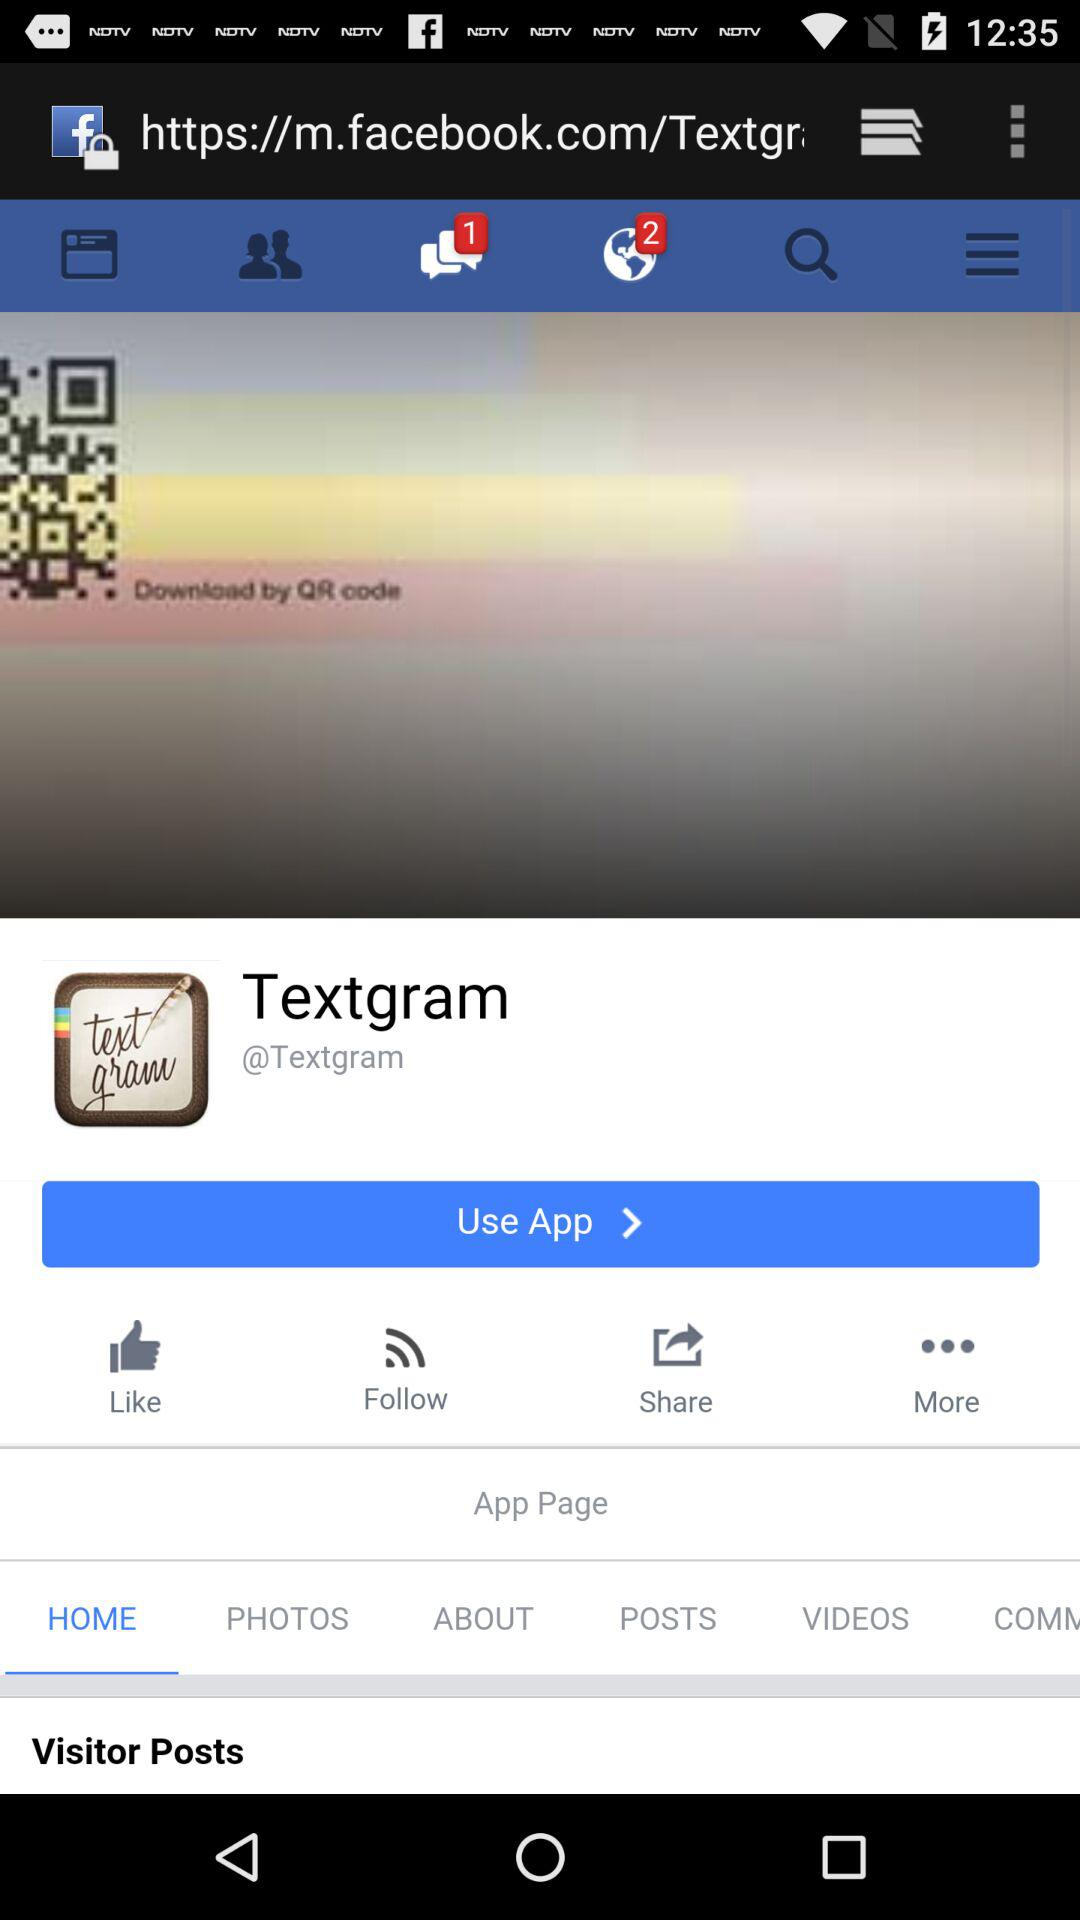What is the number of unread messages? The number of unread messages is 1. 